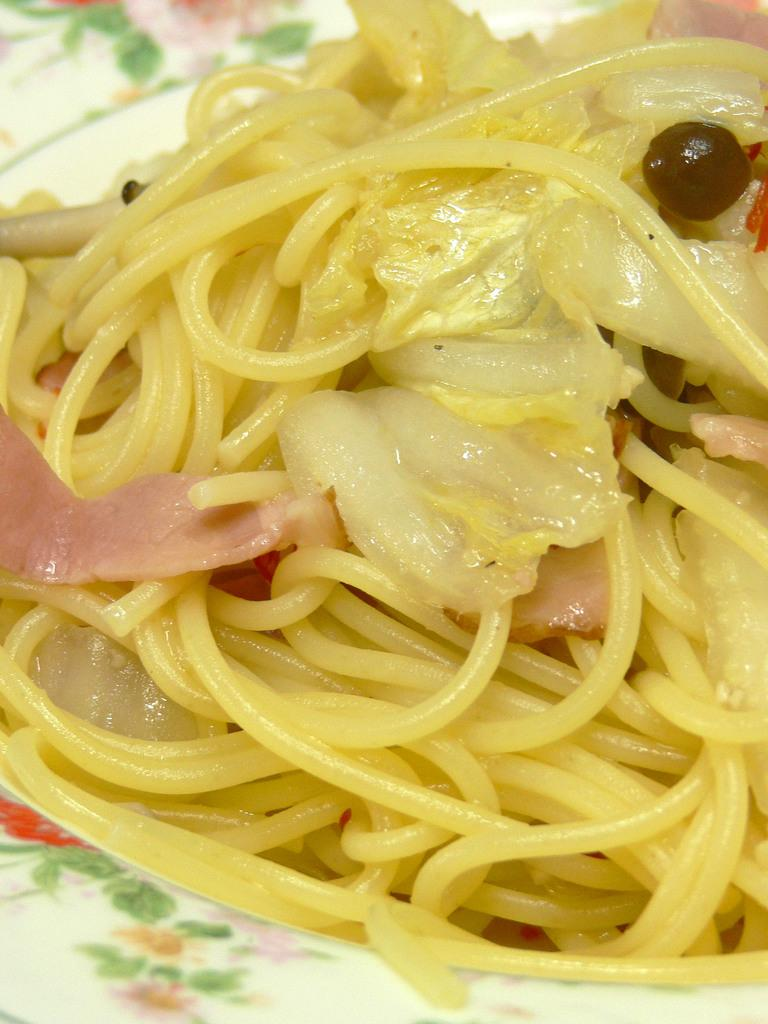What is on the plate in the image? There are noodles in the plate. Can you describe the main food item in the image? The main food item in the image is noodles. How many cubs are playing with a bat in the image? There are no cubs or bats present in the image; it only features a plate with noodles. 